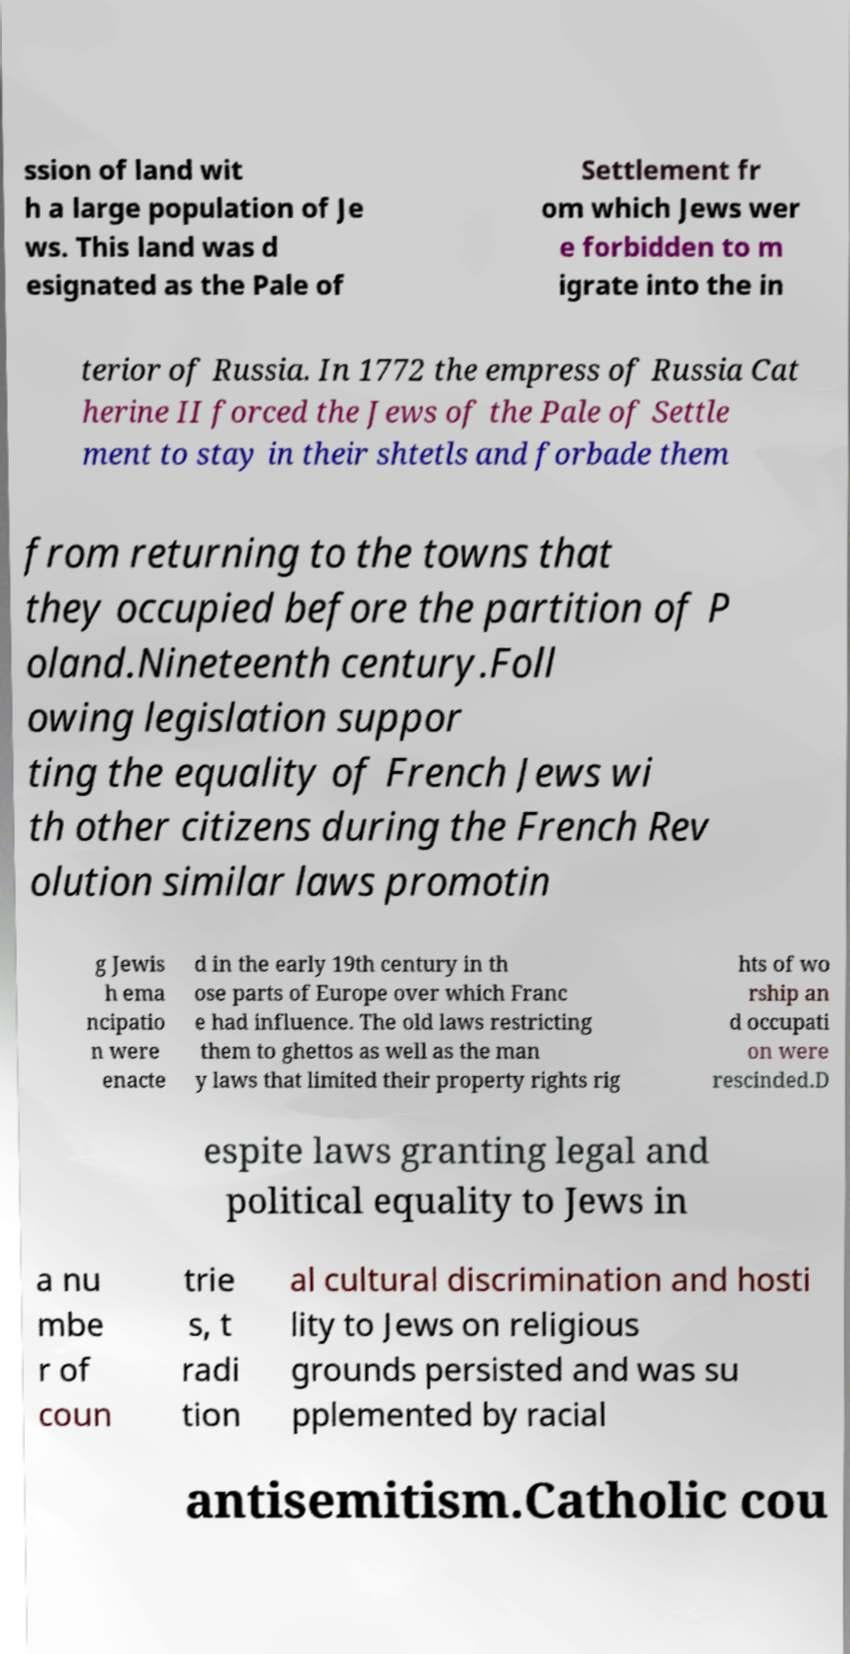Please read and relay the text visible in this image. What does it say? ssion of land wit h a large population of Je ws. This land was d esignated as the Pale of Settlement fr om which Jews wer e forbidden to m igrate into the in terior of Russia. In 1772 the empress of Russia Cat herine II forced the Jews of the Pale of Settle ment to stay in their shtetls and forbade them from returning to the towns that they occupied before the partition of P oland.Nineteenth century.Foll owing legislation suppor ting the equality of French Jews wi th other citizens during the French Rev olution similar laws promotin g Jewis h ema ncipatio n were enacte d in the early 19th century in th ose parts of Europe over which Franc e had influence. The old laws restricting them to ghettos as well as the man y laws that limited their property rights rig hts of wo rship an d occupati on were rescinded.D espite laws granting legal and political equality to Jews in a nu mbe r of coun trie s, t radi tion al cultural discrimination and hosti lity to Jews on religious grounds persisted and was su pplemented by racial antisemitism.Catholic cou 